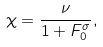Convert formula to latex. <formula><loc_0><loc_0><loc_500><loc_500>\chi = \frac { \nu } { 1 + F _ { 0 } ^ { \sigma } } ,</formula> 